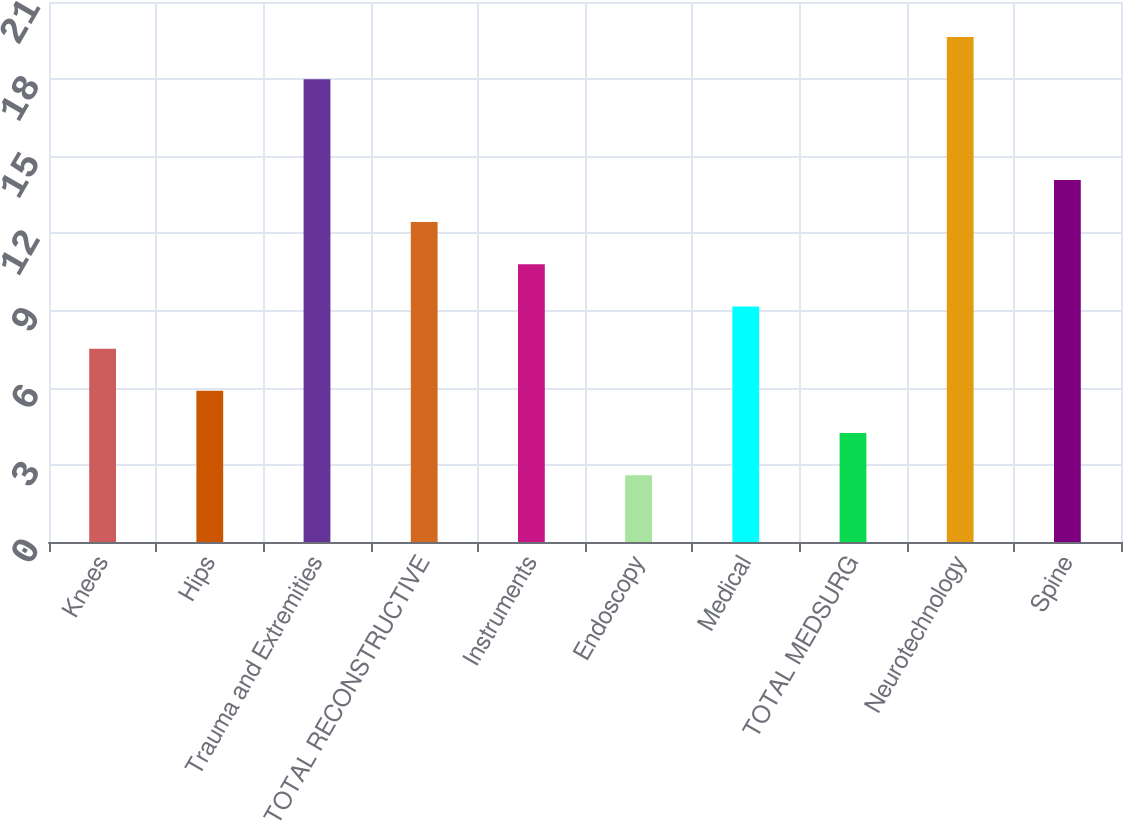Convert chart to OTSL. <chart><loc_0><loc_0><loc_500><loc_500><bar_chart><fcel>Knees<fcel>Hips<fcel>Trauma and Extremities<fcel>TOTAL RECONSTRUCTIVE<fcel>Instruments<fcel>Endoscopy<fcel>Medical<fcel>TOTAL MEDSURG<fcel>Neurotechnology<fcel>Spine<nl><fcel>7.52<fcel>5.88<fcel>18<fcel>12.44<fcel>10.8<fcel>2.6<fcel>9.16<fcel>4.24<fcel>19.64<fcel>14.08<nl></chart> 